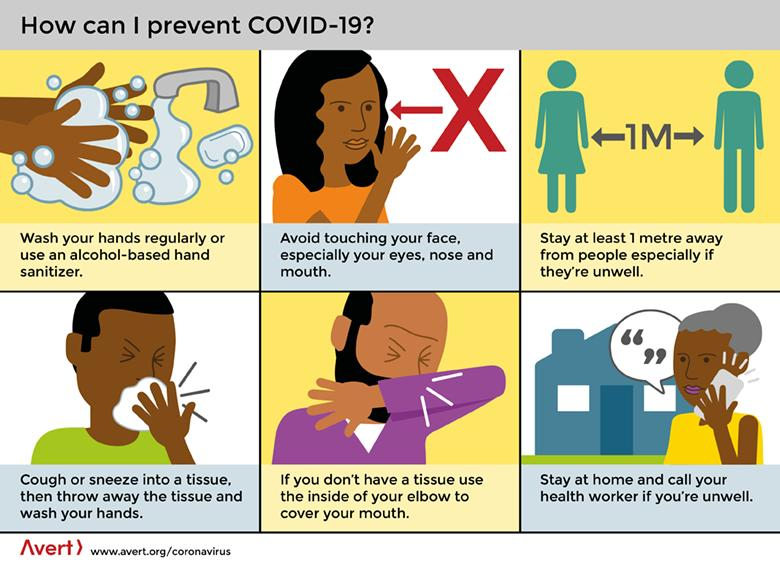Mention a couple of crucial points in this snapshot. When given a tip in the middle of the second row, it is appropriate to use the inside of your elbow to cover your mouth if you do not have a tissue available. This infographic provides 6 tips to prevent COVID-19. It is important to give a tip of at least 1 meter distance from people, especially if they are unwell, as advised at the end of the first row. 